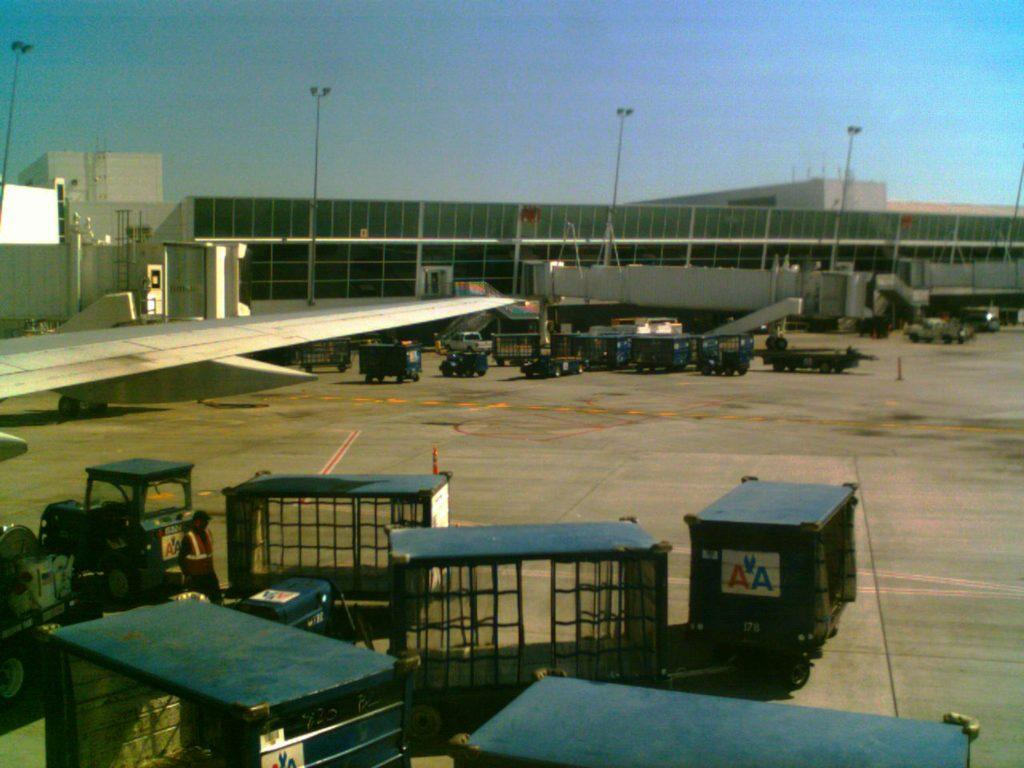<image>
Relay a brief, clear account of the picture shown. An airport has lots of blue carts that say AA. 